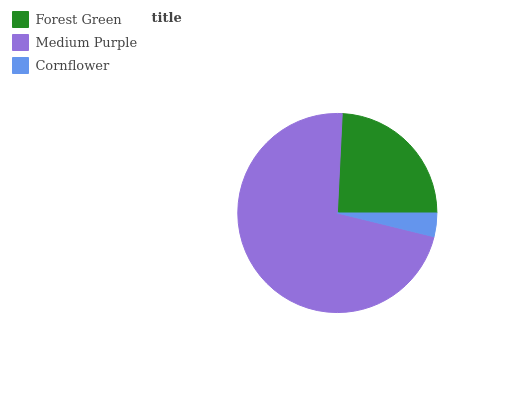Is Cornflower the minimum?
Answer yes or no. Yes. Is Medium Purple the maximum?
Answer yes or no. Yes. Is Medium Purple the minimum?
Answer yes or no. No. Is Cornflower the maximum?
Answer yes or no. No. Is Medium Purple greater than Cornflower?
Answer yes or no. Yes. Is Cornflower less than Medium Purple?
Answer yes or no. Yes. Is Cornflower greater than Medium Purple?
Answer yes or no. No. Is Medium Purple less than Cornflower?
Answer yes or no. No. Is Forest Green the high median?
Answer yes or no. Yes. Is Forest Green the low median?
Answer yes or no. Yes. Is Cornflower the high median?
Answer yes or no. No. Is Medium Purple the low median?
Answer yes or no. No. 